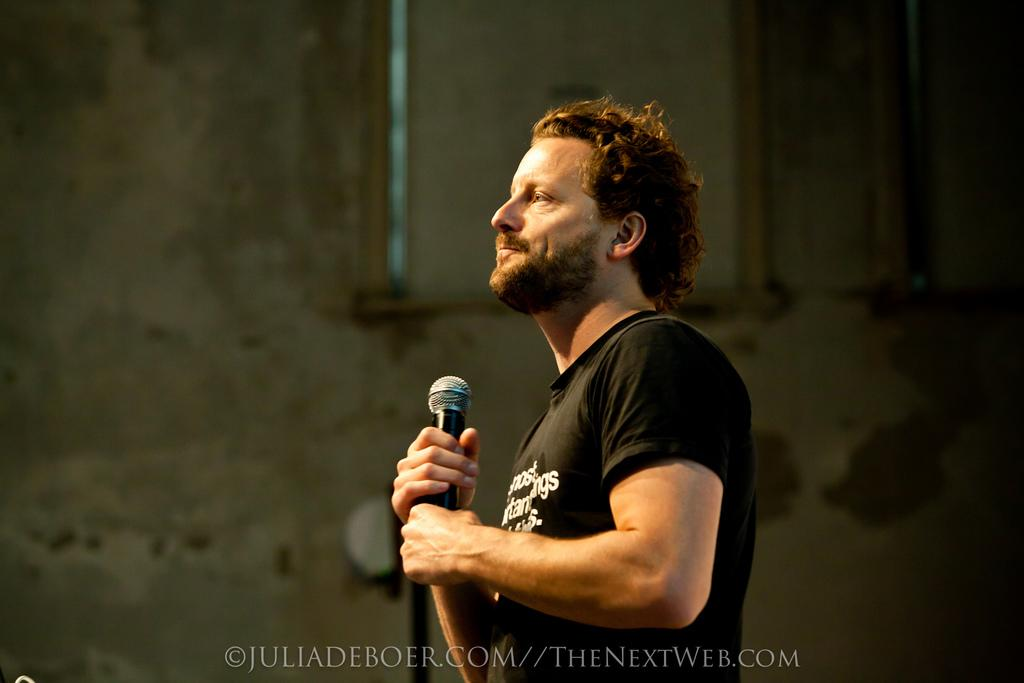What is the main subject of the image? The main subject of the image is a man. What is the man doing in the image? The man is standing and holding a microphone. What is the man wearing in the image? The man is wearing a black color t-shirt. What can be seen in the background of the image? There is a wall in the background of the image. What additional information is provided at the bottom of the image? There is some text visible at the bottom of the image. What type of truck can be seen in the image? There is no truck present in the image. How many letters are visible on the man's t-shirt in the image? The provided facts do not specify the number of letters on the man's t-shirt, only that it is black. Is there a sink visible in the image? There is no sink present in the image. 